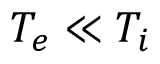Convert formula to latex. <formula><loc_0><loc_0><loc_500><loc_500>T _ { e } \ll T _ { i }</formula> 